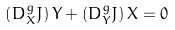<formula> <loc_0><loc_0><loc_500><loc_500>\left ( D ^ { g } _ { X } J \right ) Y + \left ( D ^ { g } _ { Y } J \right ) X = 0</formula> 